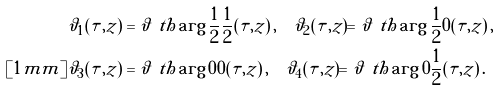Convert formula to latex. <formula><loc_0><loc_0><loc_500><loc_500>\vartheta _ { 1 } ( \tau , z ) & = \vartheta \ t h \arg { \frac { 1 } { 2 } } { \frac { 1 } { 2 } } ( \tau , z ) \, , \quad \vartheta _ { 2 } ( \tau , z ) = \vartheta \ t h \arg { \frac { 1 } { 2 } } { 0 } ( \tau , z ) \, , \\ [ 1 m m ] \vartheta _ { 3 } ( \tau , z ) & = \vartheta \ t h \arg { 0 } { 0 } ( \tau , z ) \, , \quad \vartheta _ { 4 } ( \tau , z ) = \vartheta \ t h \arg { 0 } { \frac { 1 } { 2 } } ( \tau , z ) \, .</formula> 